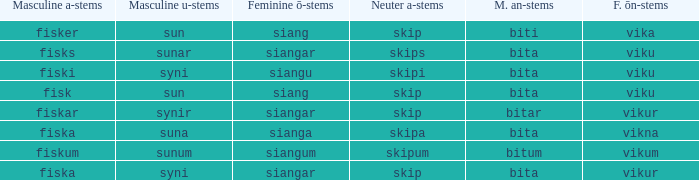What is the u form of the word with a neuter form of skip and a masculine a-ending of fisker? Sun. 